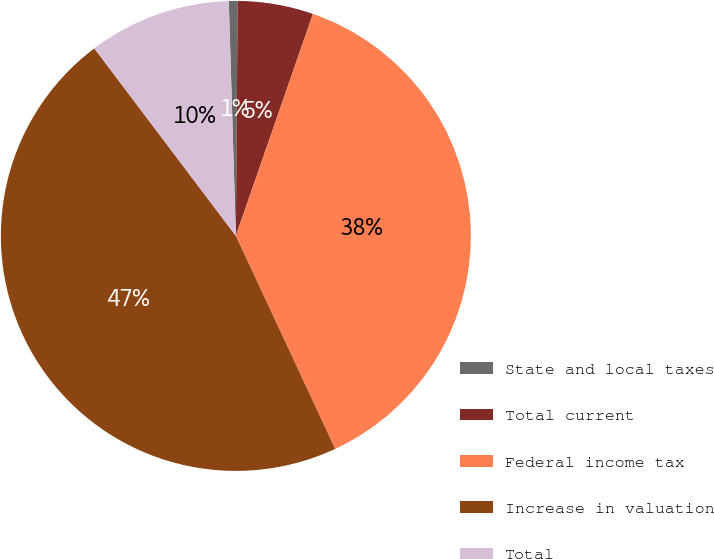Convert chart. <chart><loc_0><loc_0><loc_500><loc_500><pie_chart><fcel>State and local taxes<fcel>Total current<fcel>Federal income tax<fcel>Increase in valuation<fcel>Total<nl><fcel>0.6%<fcel>5.2%<fcel>37.74%<fcel>46.66%<fcel>9.81%<nl></chart> 